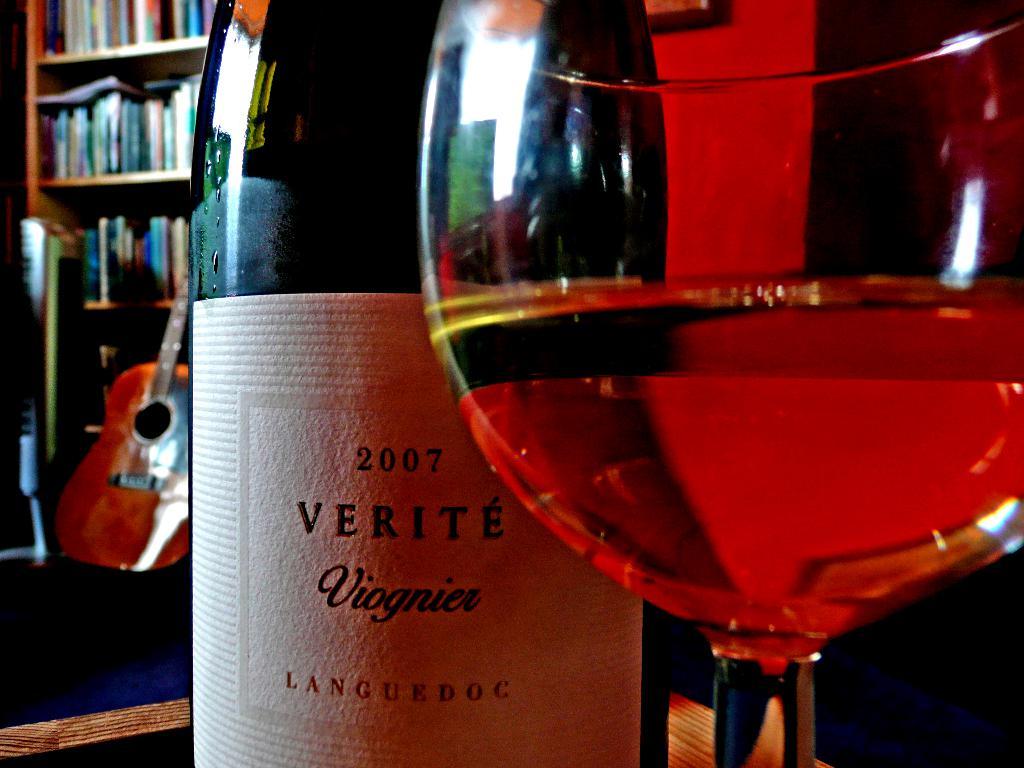What year is inscribed on the bottle?
Provide a short and direct response. 2007. 